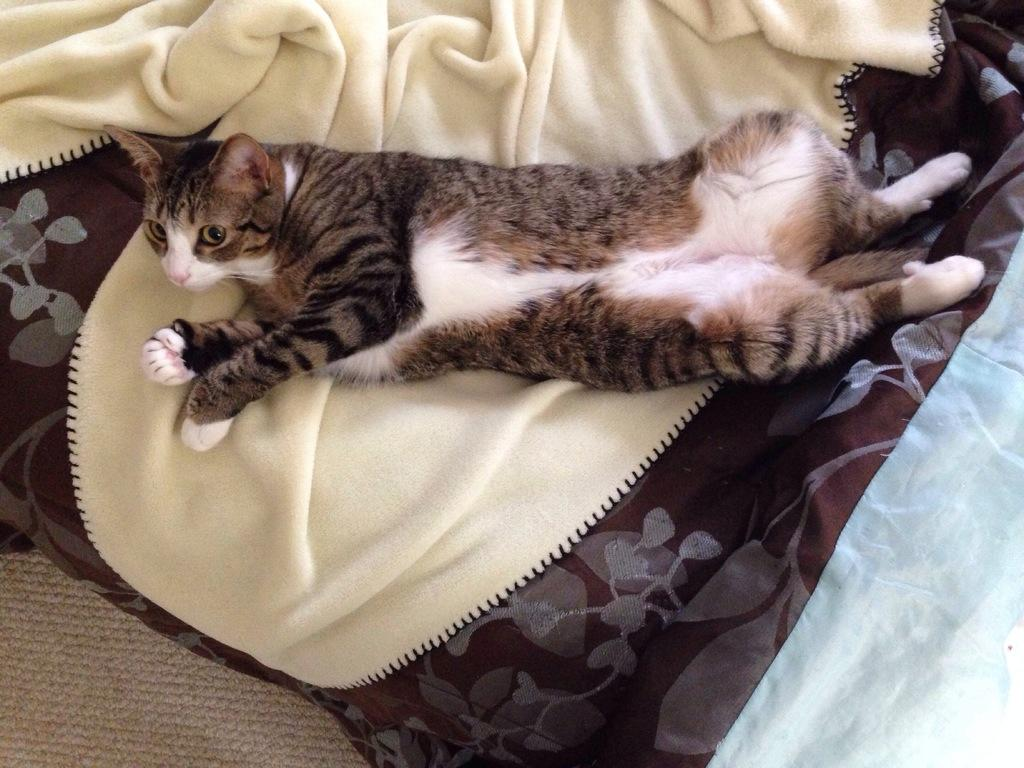What type of animal is in the image? There is a black and white cat in the image. Where is the cat located? The cat is lying on a sofa. What color is the blanket visible in the image? The blanket is yellow. Is the cat wearing a vest in the image? There is no mention of a vest in the image, and the cat is not wearing any clothing. 